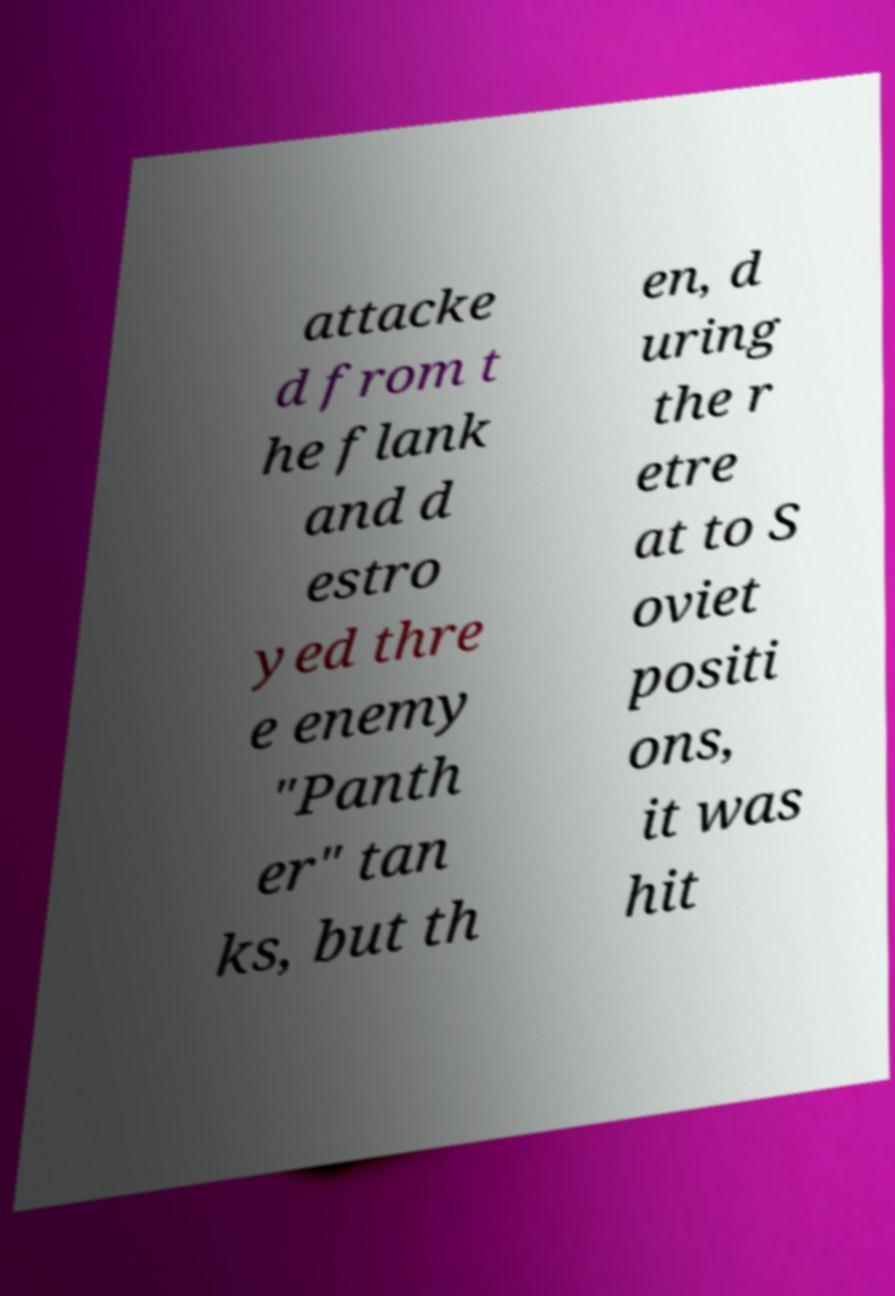Could you extract and type out the text from this image? attacke d from t he flank and d estro yed thre e enemy "Panth er" tan ks, but th en, d uring the r etre at to S oviet positi ons, it was hit 